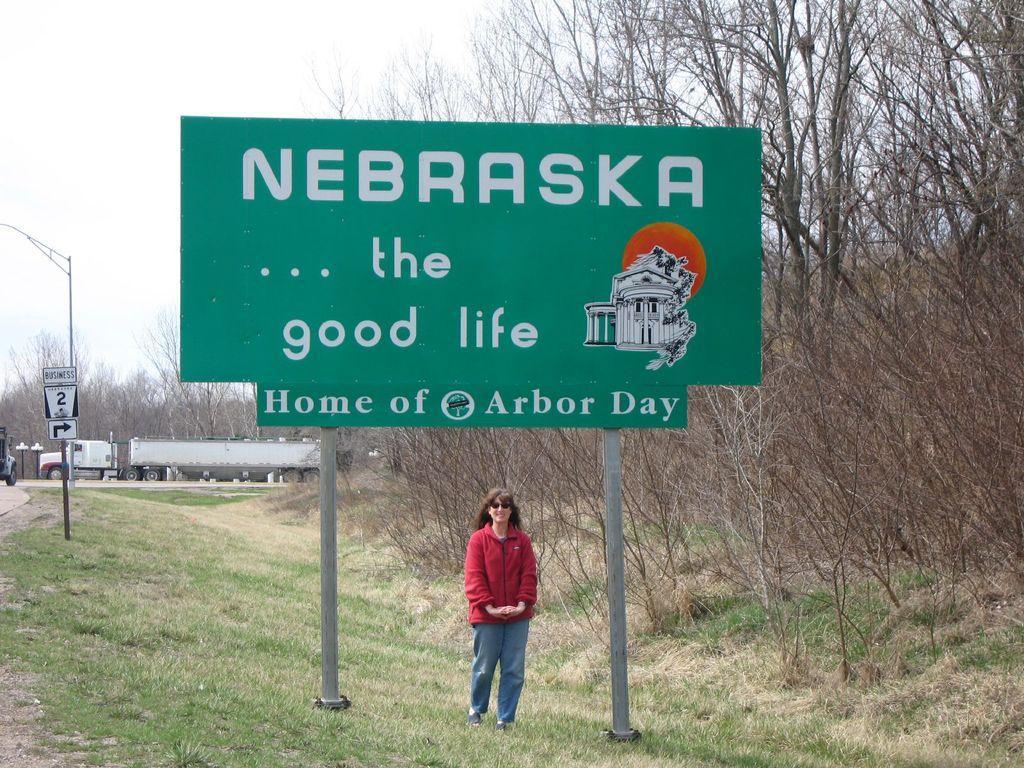Can you describe this image briefly? In the foreground I can see a woman is standing on the grass and a board. In the background I can see trees, poles, vehicles on the road and the sky. This image is taken may be during a day. 